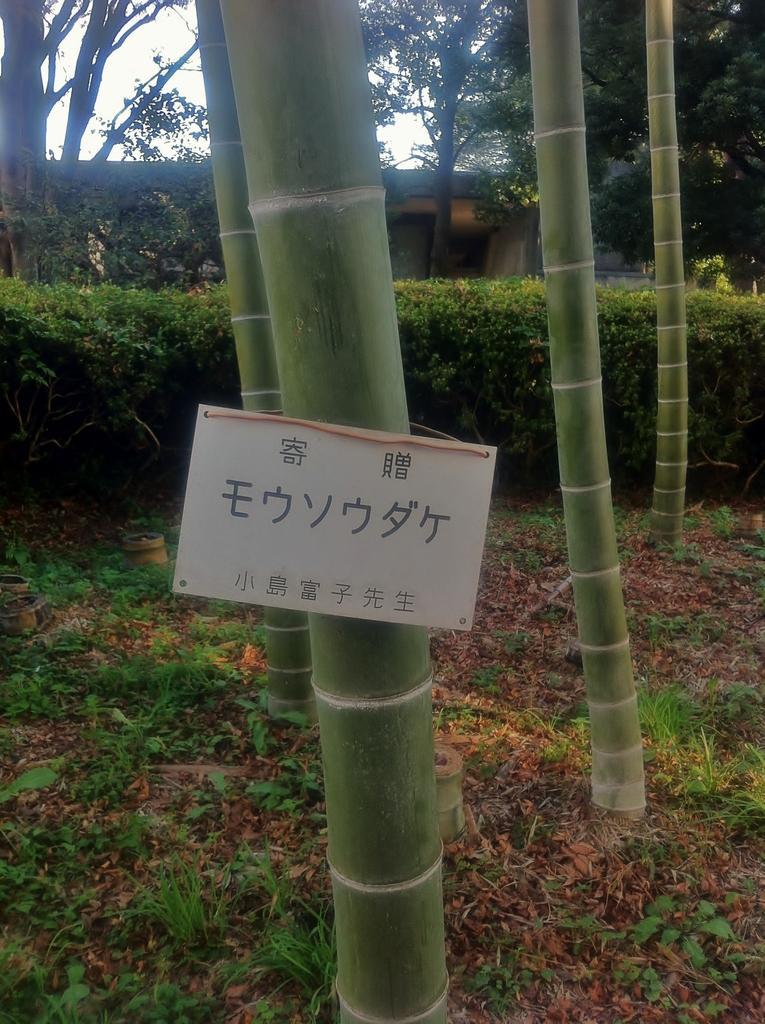Describe this image in one or two sentences. In the center of the image we can see a few bamboo sticks. On the front bamboo stick, we can see one banner. On the banner, we can see some text. In the background we can see the sky, clouds, trees, plants, grass etc. 